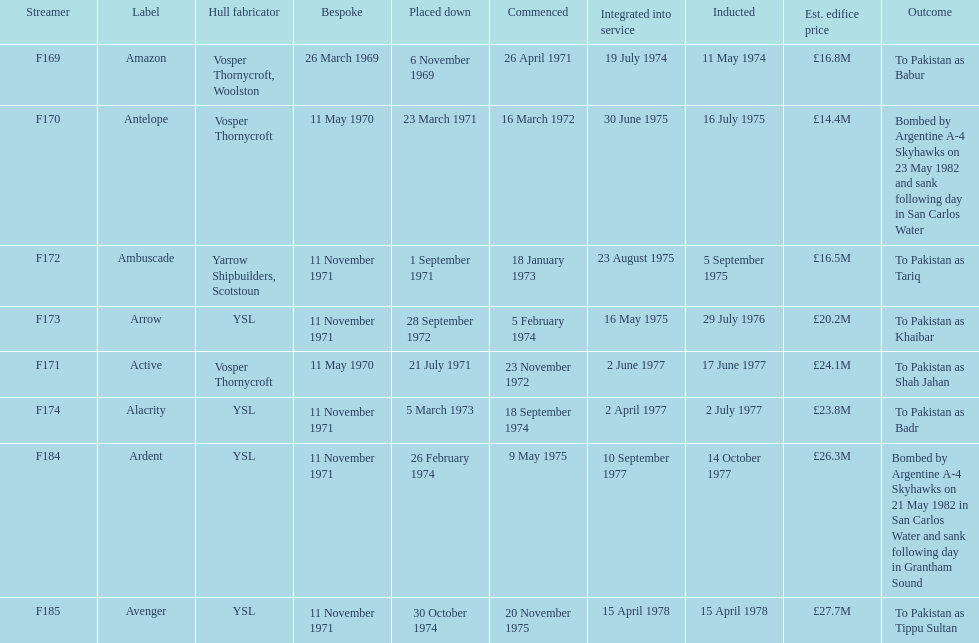Amazon is at the top of the chart, but what is the name below it? Antelope. 